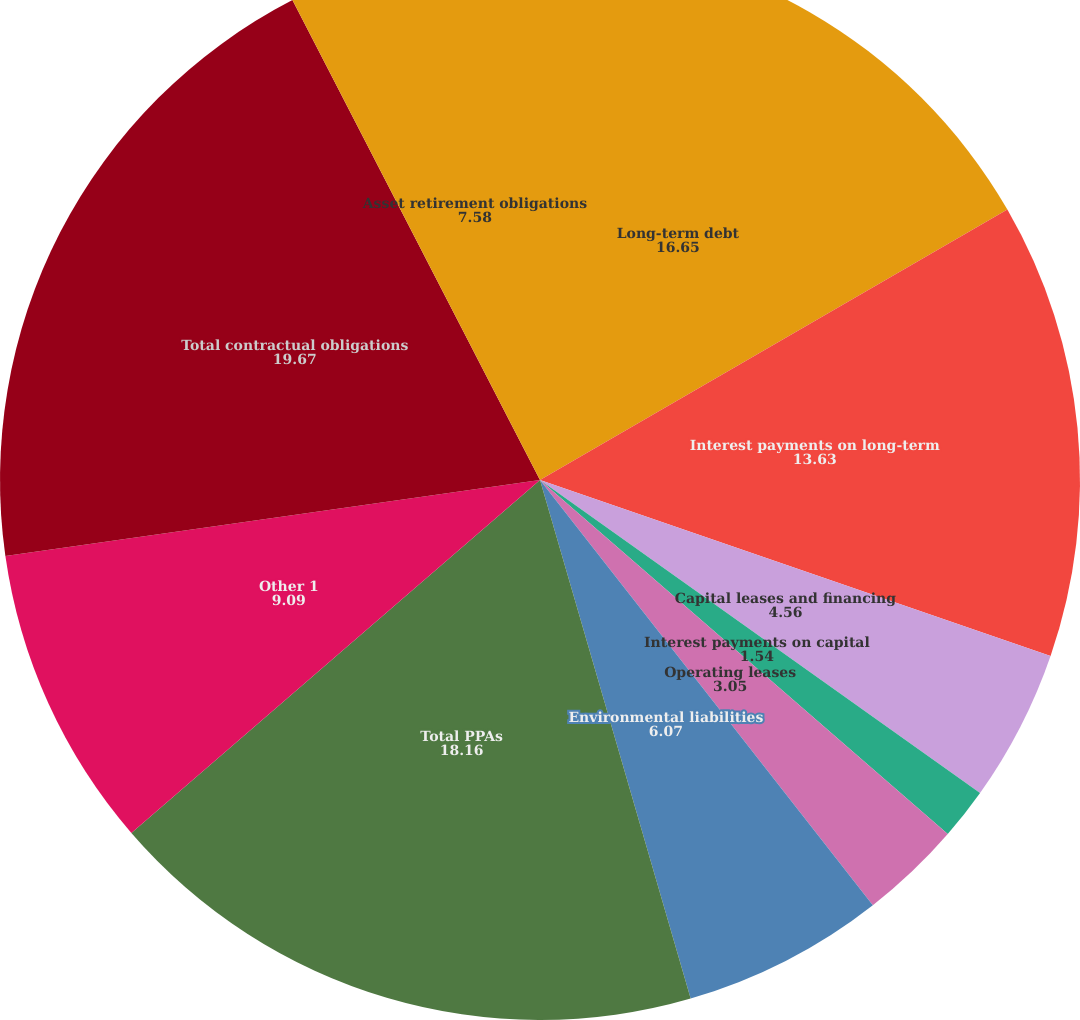Convert chart. <chart><loc_0><loc_0><loc_500><loc_500><pie_chart><fcel>Long-term debt<fcel>Interest payments on long-term<fcel>Capital leases and financing<fcel>Interest payments on capital<fcel>Operating leases<fcel>Environmental liabilities<fcel>Total PPAs<fcel>Other 1<fcel>Total contractual obligations<fcel>Asset retirement obligations<nl><fcel>16.65%<fcel>13.63%<fcel>4.56%<fcel>1.54%<fcel>3.05%<fcel>6.07%<fcel>18.16%<fcel>9.09%<fcel>19.67%<fcel>7.58%<nl></chart> 